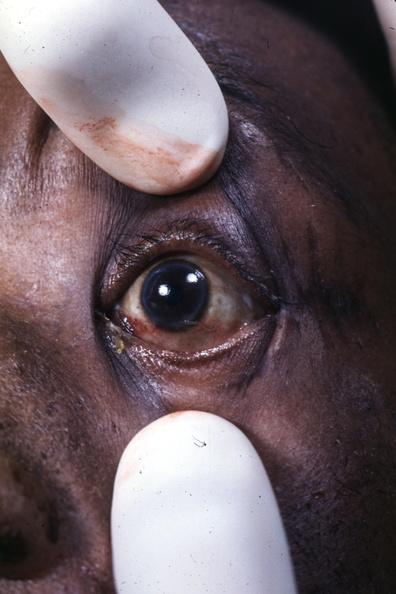what is present?
Answer the question using a single word or phrase. Eye 